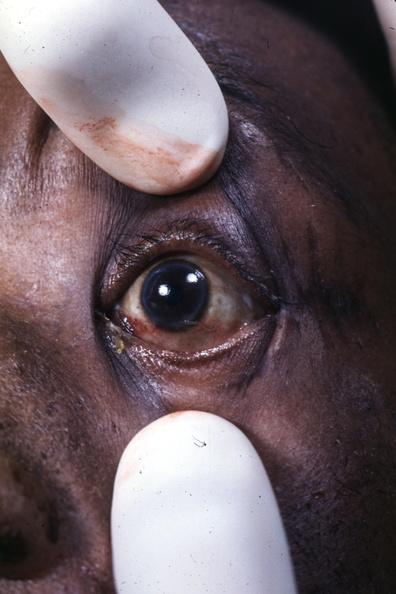what is present?
Answer the question using a single word or phrase. Eye 